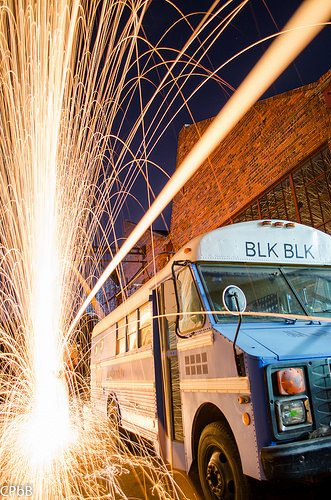<image>
Is the bus next to the fireworks? Yes. The bus is positioned adjacent to the fireworks, located nearby in the same general area. Is there a bus behind the spark? Yes. From this viewpoint, the bus is positioned behind the spark, with the spark partially or fully occluding the bus. 